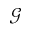<formula> <loc_0><loc_0><loc_500><loc_500>\mathcal { G }</formula> 